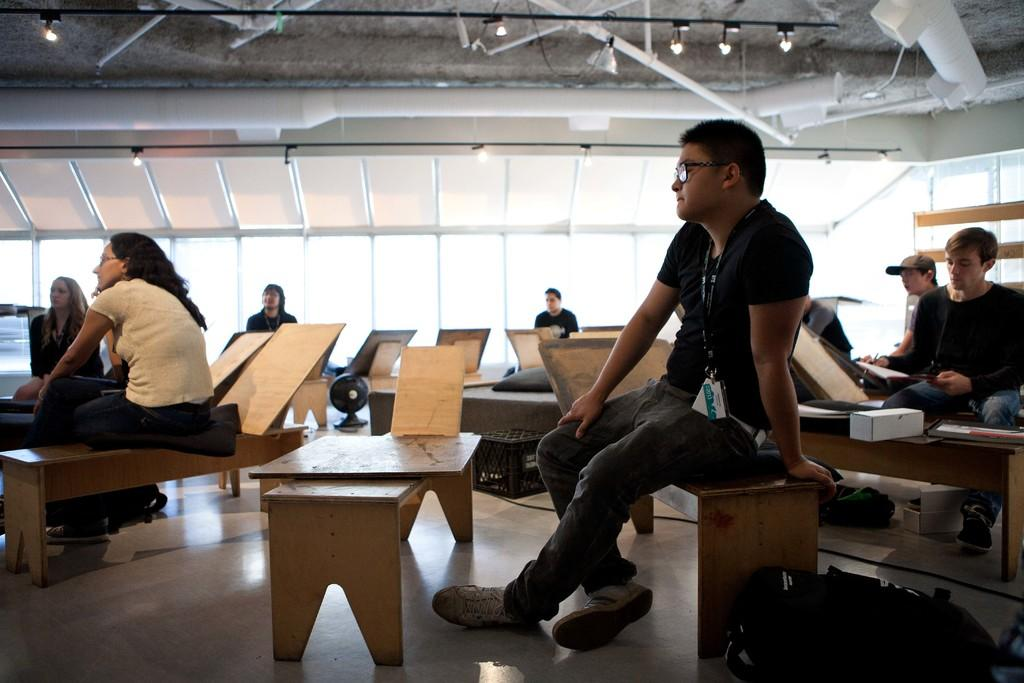What type of seating is visible in the image? There are benches in the image. Can you describe the person sitting on one of the benches? The person is wearing a black t-shirt and pants. What is the woman in the image doing? The woman is wearing a white t-shirt and watching. What type of fruit is the person eating while sitting on the bench? There is no fruit visible in the image, and the person is not eating anything. 